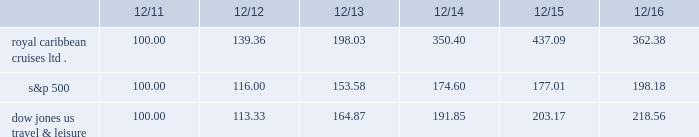Performance graph the following graph compares the total return , assuming reinvestment of dividends , on an investment in the company , based on performance of the company's common stock , with the total return of the standard & poor's 500 composite stock index and the dow jones united states travel and leisure index for a five year period by measuring the changes in common stock prices from december 31 , 2011 to december 31 , 2016. .
The stock performance graph assumes for comparison that the value of the company's common stock and of each index was $ 100 on december 31 , 2011 and that all dividends were reinvested .
Past performance is not necessarily an indicator of future results. .
What is the percentage increase of the s&p 500 from 2011 to 2016? 
Computations: (((198.18 - 100) / 100) * 100)
Answer: 98.18. 